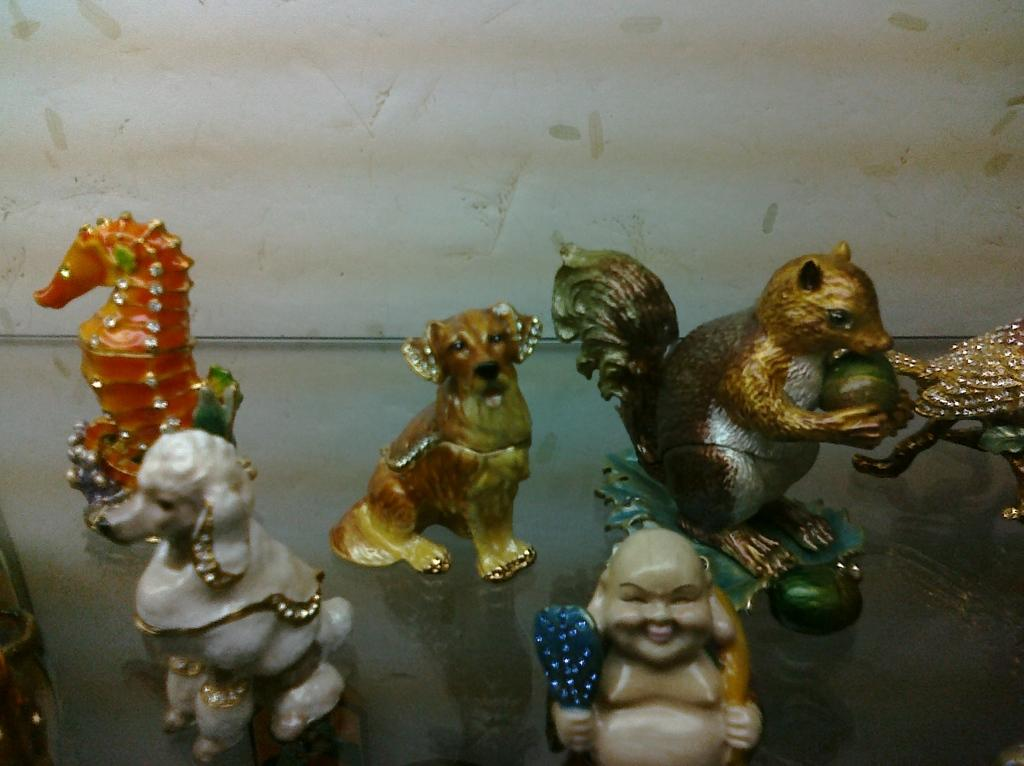What types of objects are present in the image? There are toys of different shapes and sizes in the image. What can be seen in the background of the image? There is a wall visible in the image. Are there any dinosaurs visible in the image? No, there are no dinosaurs present in the image. What type of trouble might the toys be causing in the image? The toys themselves are not causing any trouble, as they are inanimate objects. 